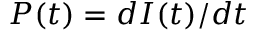<formula> <loc_0><loc_0><loc_500><loc_500>P ( t ) = d I ( t ) / d t</formula> 